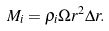<formula> <loc_0><loc_0><loc_500><loc_500>M _ { i } = \rho _ { i } \Omega r ^ { 2 } \Delta r .</formula> 